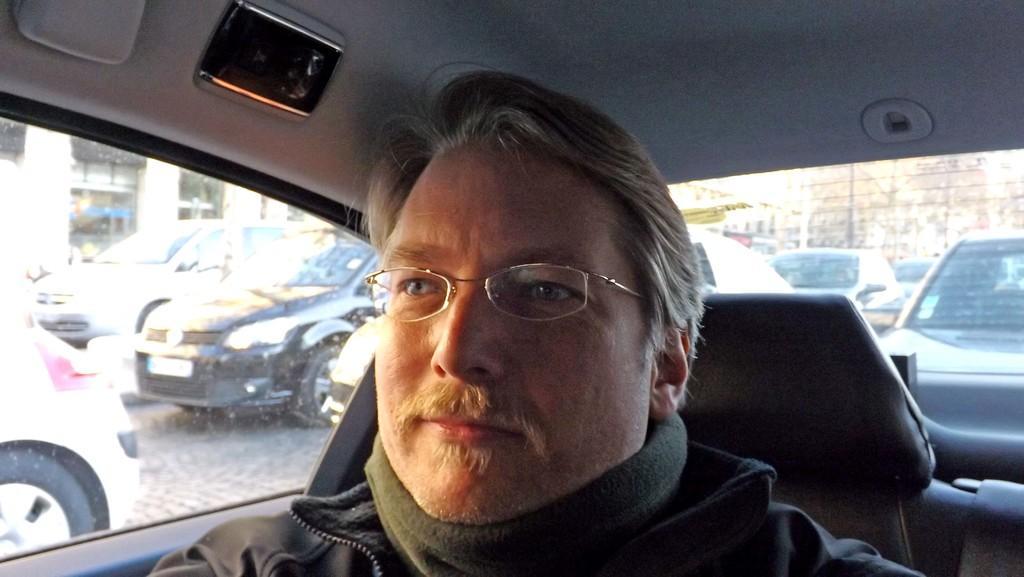In one or two sentences, can you explain what this image depicts? In this picture we can see man wore spectacle, jacket and he is smiling and sitting inside the car and from window we can see cars on road, building with windows, fence. 